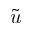Convert formula to latex. <formula><loc_0><loc_0><loc_500><loc_500>\tilde { u }</formula> 